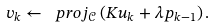<formula> <loc_0><loc_0><loc_500><loc_500>v _ { k } \leftarrow \ p r o j _ { \mathcal { C } } \left ( K u _ { k } + \lambda p _ { k - 1 } \right ) .</formula> 